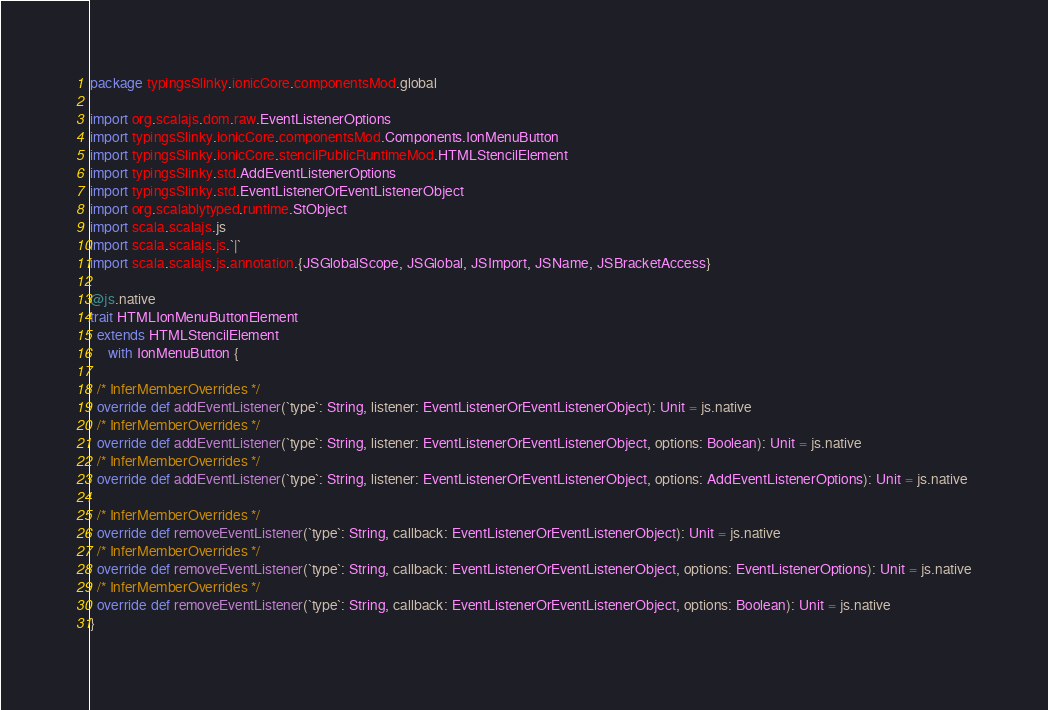<code> <loc_0><loc_0><loc_500><loc_500><_Scala_>package typingsSlinky.ionicCore.componentsMod.global

import org.scalajs.dom.raw.EventListenerOptions
import typingsSlinky.ionicCore.componentsMod.Components.IonMenuButton
import typingsSlinky.ionicCore.stencilPublicRuntimeMod.HTMLStencilElement
import typingsSlinky.std.AddEventListenerOptions
import typingsSlinky.std.EventListenerOrEventListenerObject
import org.scalablytyped.runtime.StObject
import scala.scalajs.js
import scala.scalajs.js.`|`
import scala.scalajs.js.annotation.{JSGlobalScope, JSGlobal, JSImport, JSName, JSBracketAccess}

@js.native
trait HTMLIonMenuButtonElement
  extends HTMLStencilElement
     with IonMenuButton {
  
  /* InferMemberOverrides */
  override def addEventListener(`type`: String, listener: EventListenerOrEventListenerObject): Unit = js.native
  /* InferMemberOverrides */
  override def addEventListener(`type`: String, listener: EventListenerOrEventListenerObject, options: Boolean): Unit = js.native
  /* InferMemberOverrides */
  override def addEventListener(`type`: String, listener: EventListenerOrEventListenerObject, options: AddEventListenerOptions): Unit = js.native
  
  /* InferMemberOverrides */
  override def removeEventListener(`type`: String, callback: EventListenerOrEventListenerObject): Unit = js.native
  /* InferMemberOverrides */
  override def removeEventListener(`type`: String, callback: EventListenerOrEventListenerObject, options: EventListenerOptions): Unit = js.native
  /* InferMemberOverrides */
  override def removeEventListener(`type`: String, callback: EventListenerOrEventListenerObject, options: Boolean): Unit = js.native
}
</code> 